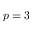<formula> <loc_0><loc_0><loc_500><loc_500>p = 3</formula> 